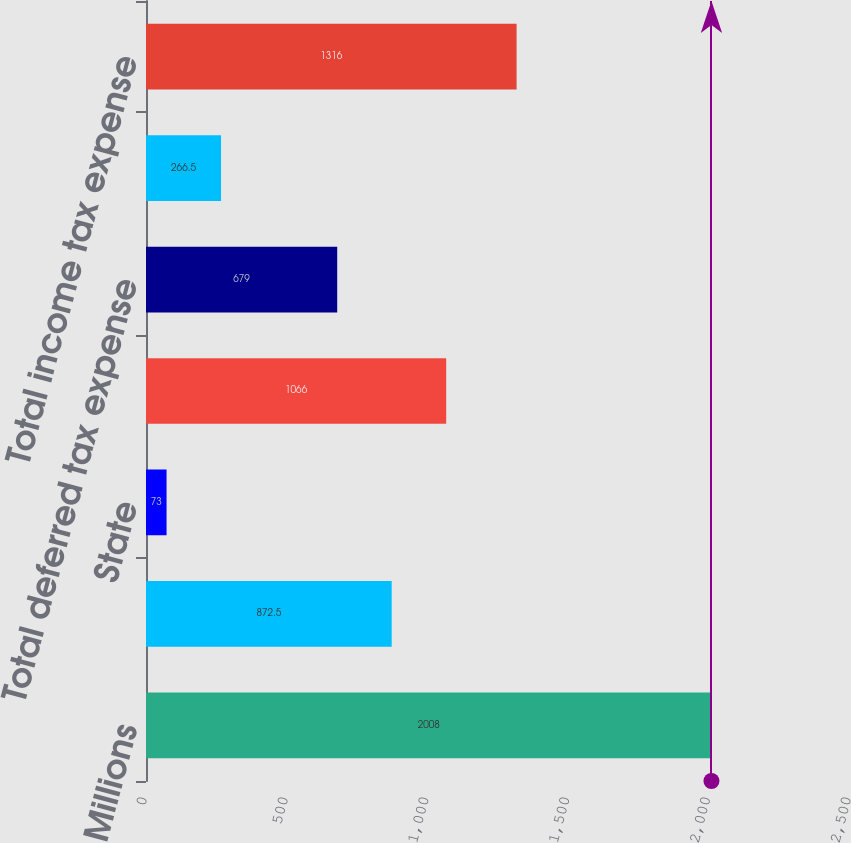<chart> <loc_0><loc_0><loc_500><loc_500><bar_chart><fcel>Millions<fcel>Federal<fcel>State<fcel>Total current tax expense<fcel>Total deferred tax expense<fcel>Total unrecognized tax<fcel>Total income tax expense<nl><fcel>2008<fcel>872.5<fcel>73<fcel>1066<fcel>679<fcel>266.5<fcel>1316<nl></chart> 